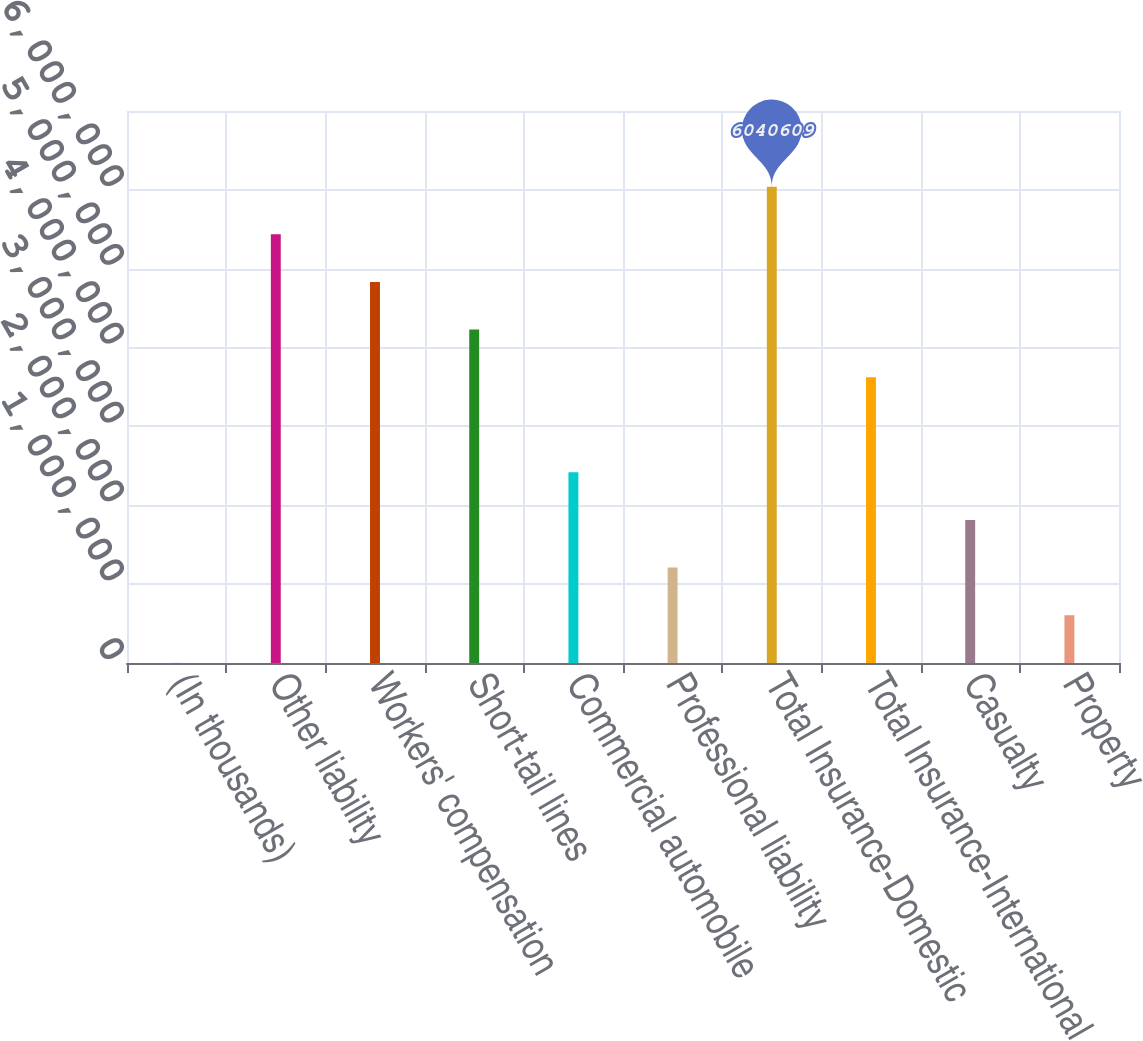Convert chart to OTSL. <chart><loc_0><loc_0><loc_500><loc_500><bar_chart><fcel>(In thousands)<fcel>Other liability<fcel>Workers' compensation<fcel>Short-tail lines<fcel>Commercial automobile<fcel>Professional liability<fcel>Total Insurance-Domestic<fcel>Total Insurance-International<fcel>Casualty<fcel>Property<nl><fcel>2015<fcel>5.43675e+06<fcel>4.83289e+06<fcel>4.22903e+06<fcel>2.41745e+06<fcel>1.20973e+06<fcel>6.04061e+06<fcel>3.62517e+06<fcel>1.81359e+06<fcel>605874<nl></chart> 